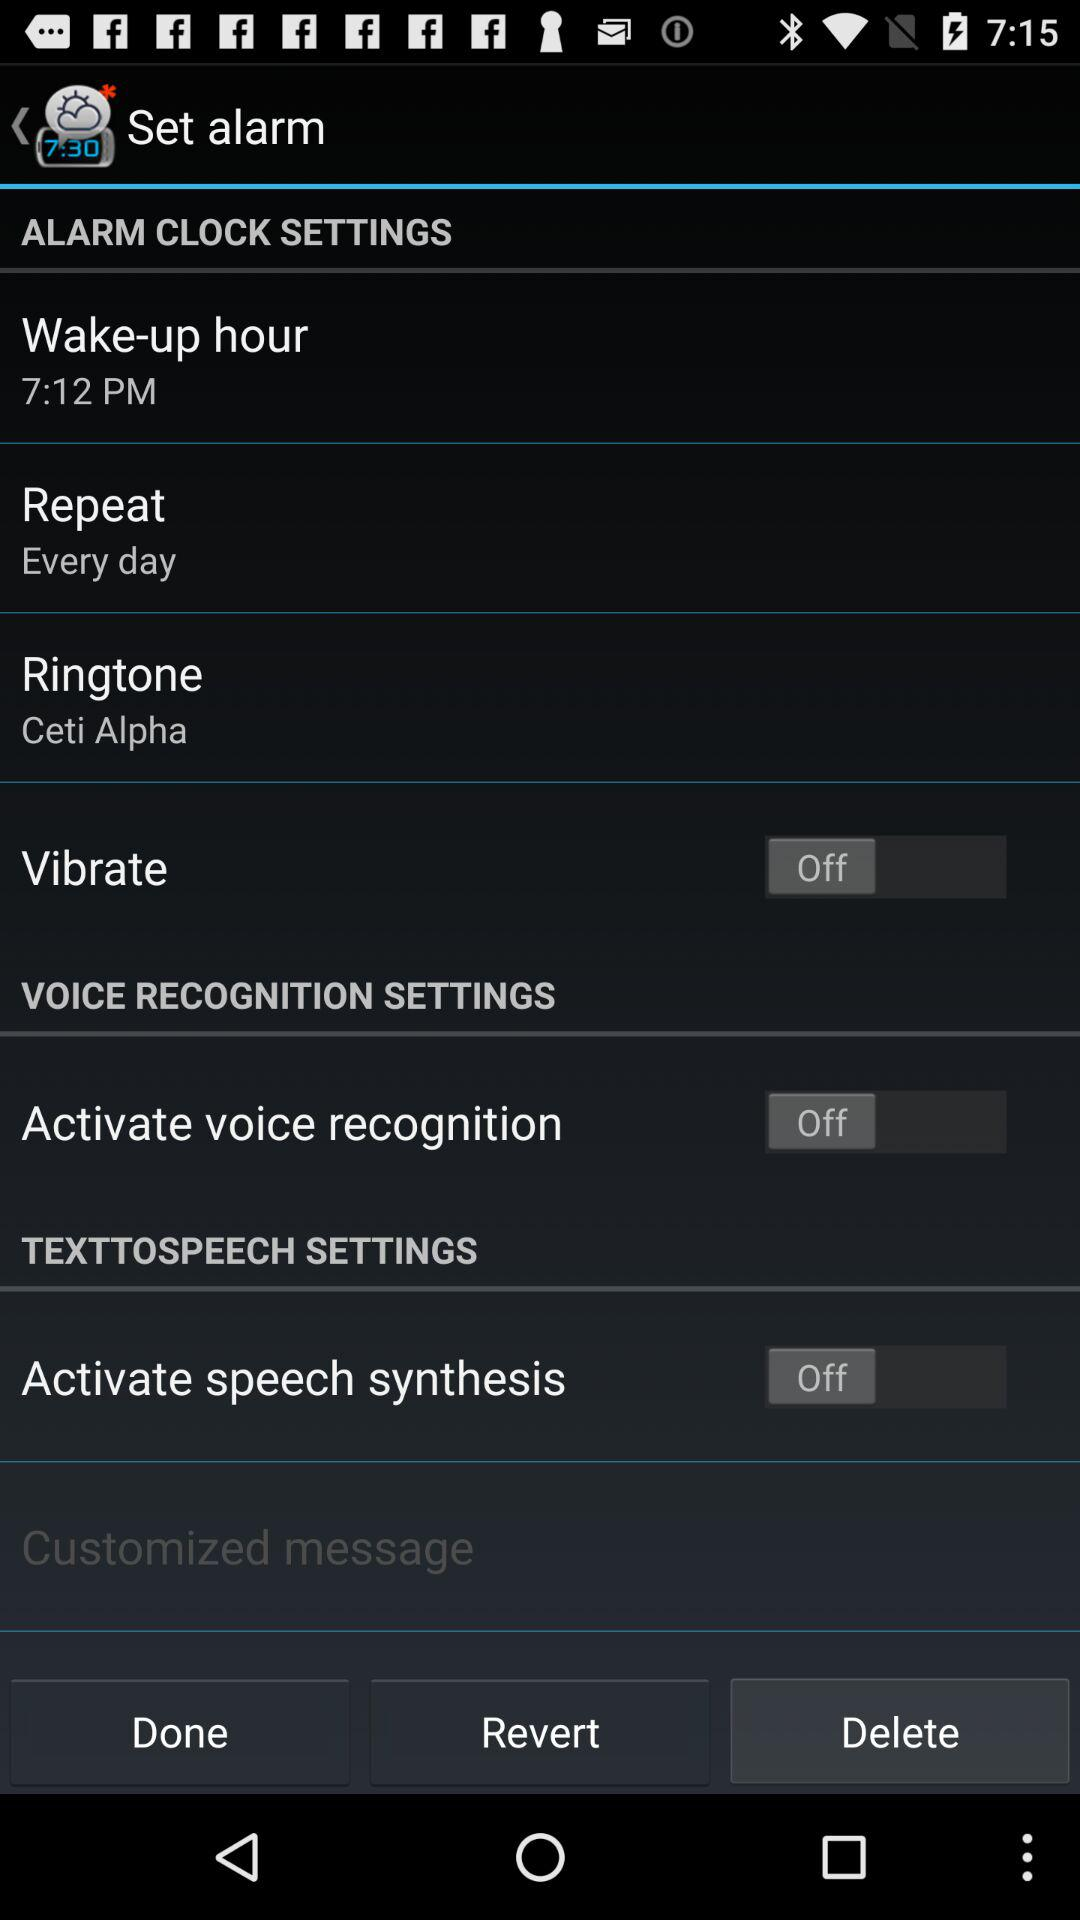What time is set for the wake-up hour? The set time for the wake-up hour is 7:12 p.m. 